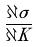<formula> <loc_0><loc_0><loc_500><loc_500>\frac { \partial \sigma } { \partial K }</formula> 